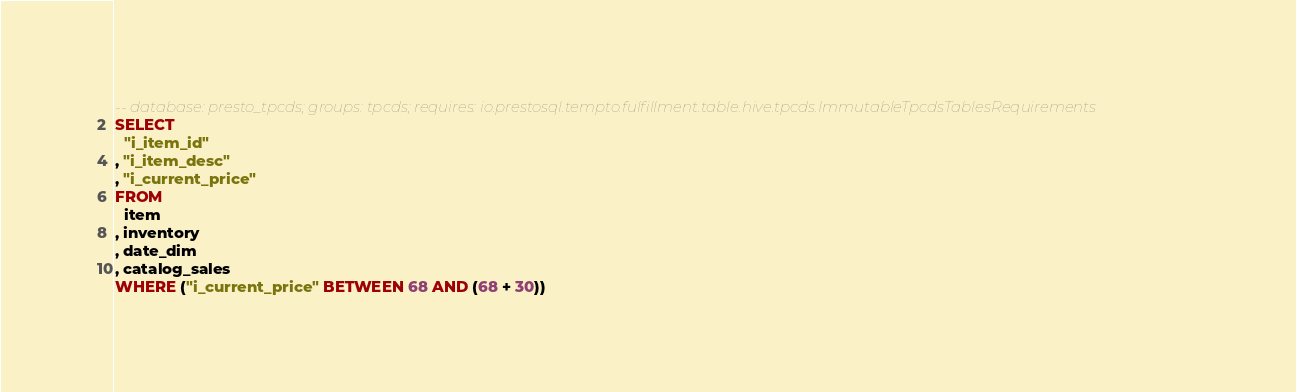Convert code to text. <code><loc_0><loc_0><loc_500><loc_500><_SQL_>-- database: presto_tpcds; groups: tpcds; requires: io.prestosql.tempto.fulfillment.table.hive.tpcds.ImmutableTpcdsTablesRequirements
SELECT
  "i_item_id"
, "i_item_desc"
, "i_current_price"
FROM
  item
, inventory
, date_dim
, catalog_sales
WHERE ("i_current_price" BETWEEN 68 AND (68 + 30))</code> 